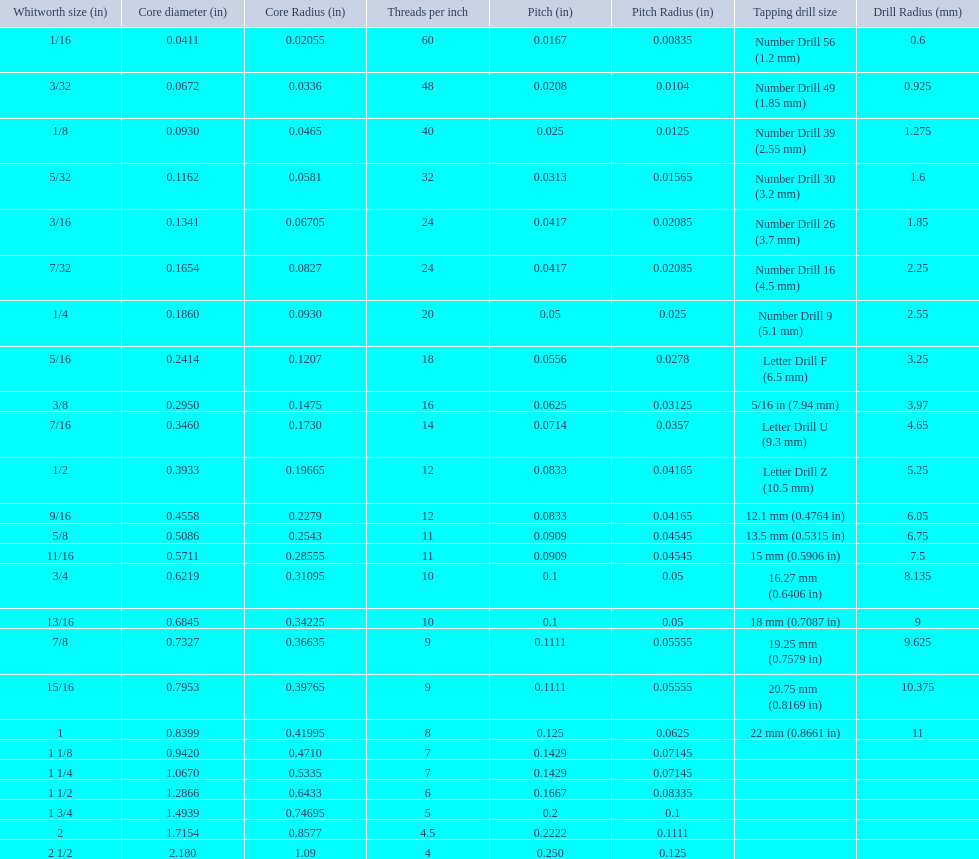What are all of the whitworth sizes? 1/16, 3/32, 1/8, 5/32, 3/16, 7/32, 1/4, 5/16, 3/8, 7/16, 1/2, 9/16, 5/8, 11/16, 3/4, 13/16, 7/8, 15/16, 1, 1 1/8, 1 1/4, 1 1/2, 1 3/4, 2, 2 1/2. How many threads per inch are in each size? 60, 48, 40, 32, 24, 24, 20, 18, 16, 14, 12, 12, 11, 11, 10, 10, 9, 9, 8, 7, 7, 6, 5, 4.5, 4. How many threads per inch are in the 3/16 size? 24. And which other size has the same number of threads? 7/32. 